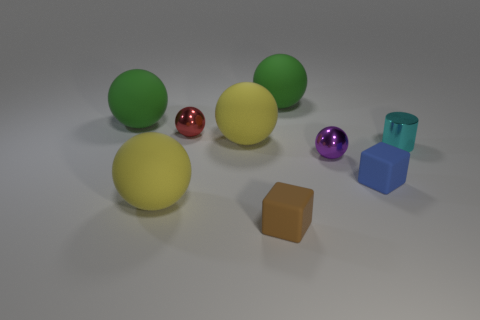There is a blue block that is to the left of the shiny cylinder; is its size the same as the brown object?
Your answer should be very brief. Yes. Is there anything else that has the same shape as the small cyan shiny object?
Provide a short and direct response. No. Does the small purple sphere have the same material as the yellow thing that is in front of the small shiny cylinder?
Ensure brevity in your answer.  No. What number of blue things are either tiny shiny objects or small matte blocks?
Provide a short and direct response. 1. Is there a tiny yellow cube?
Your answer should be compact. No. There is a rubber cube that is to the left of the tiny metallic thing that is in front of the small cyan thing; is there a big yellow rubber thing to the right of it?
Give a very brief answer. No. Is the shape of the brown thing the same as the small matte thing on the right side of the tiny purple shiny thing?
Your response must be concise. Yes. What color is the large rubber sphere that is on the left side of the large matte object in front of the tiny rubber thing that is behind the brown block?
Your answer should be very brief. Green. How many things are either yellow rubber things left of the tiny red object or large rubber balls on the right side of the tiny brown object?
Your answer should be compact. 2. Do the small object that is behind the small cyan shiny cylinder and the tiny purple object have the same shape?
Give a very brief answer. Yes. 